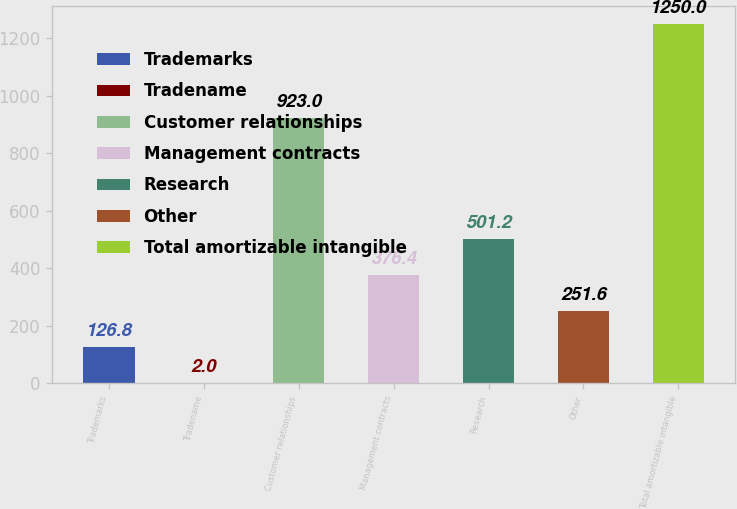Convert chart to OTSL. <chart><loc_0><loc_0><loc_500><loc_500><bar_chart><fcel>Trademarks<fcel>Tradename<fcel>Customer relationships<fcel>Management contracts<fcel>Research<fcel>Other<fcel>Total amortizable intangible<nl><fcel>126.8<fcel>2<fcel>923<fcel>376.4<fcel>501.2<fcel>251.6<fcel>1250<nl></chart> 